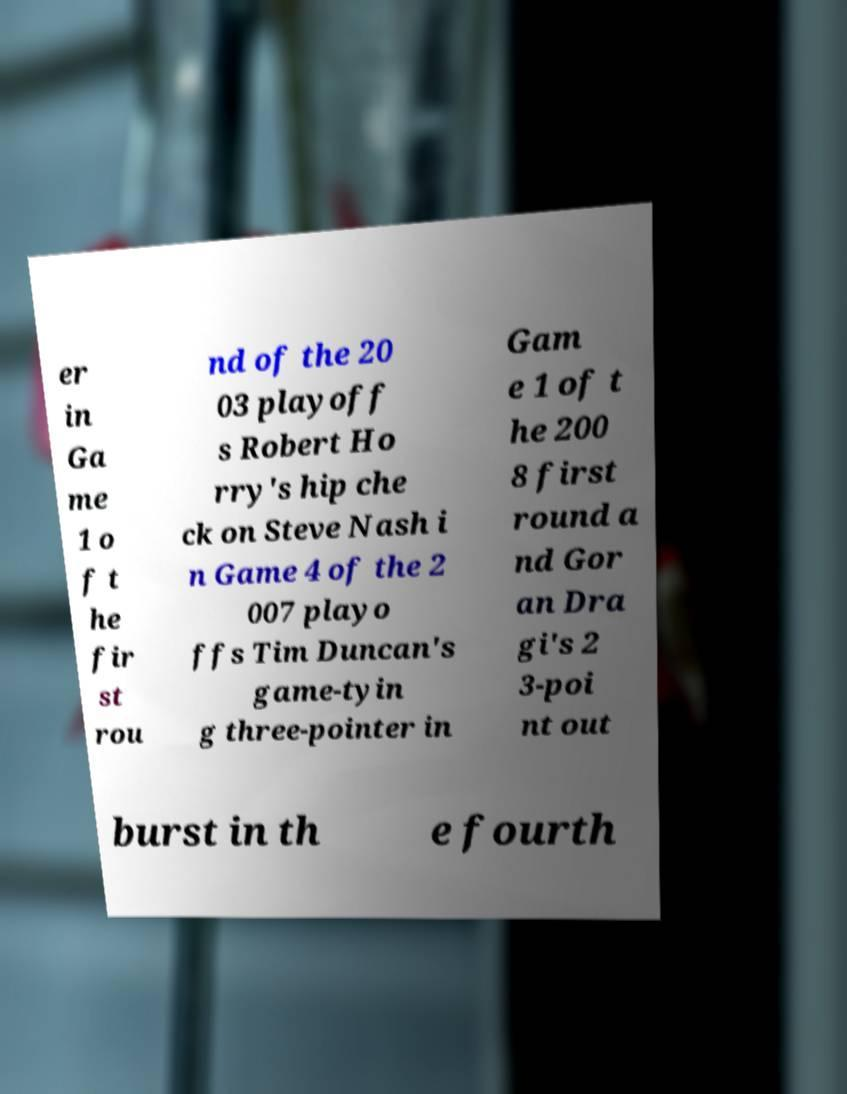Could you extract and type out the text from this image? er in Ga me 1 o f t he fir st rou nd of the 20 03 playoff s Robert Ho rry's hip che ck on Steve Nash i n Game 4 of the 2 007 playo ffs Tim Duncan's game-tyin g three-pointer in Gam e 1 of t he 200 8 first round a nd Gor an Dra gi's 2 3-poi nt out burst in th e fourth 